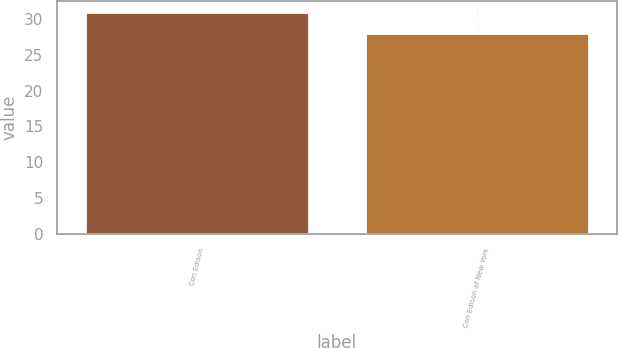<chart> <loc_0><loc_0><loc_500><loc_500><bar_chart><fcel>Con Edison<fcel>Con Edison of New York<nl><fcel>31<fcel>28<nl></chart> 